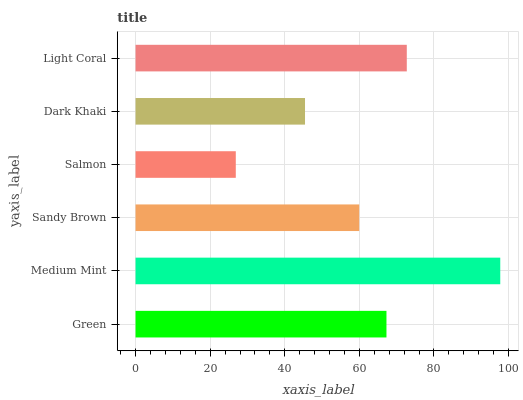Is Salmon the minimum?
Answer yes or no. Yes. Is Medium Mint the maximum?
Answer yes or no. Yes. Is Sandy Brown the minimum?
Answer yes or no. No. Is Sandy Brown the maximum?
Answer yes or no. No. Is Medium Mint greater than Sandy Brown?
Answer yes or no. Yes. Is Sandy Brown less than Medium Mint?
Answer yes or no. Yes. Is Sandy Brown greater than Medium Mint?
Answer yes or no. No. Is Medium Mint less than Sandy Brown?
Answer yes or no. No. Is Green the high median?
Answer yes or no. Yes. Is Sandy Brown the low median?
Answer yes or no. Yes. Is Dark Khaki the high median?
Answer yes or no. No. Is Green the low median?
Answer yes or no. No. 